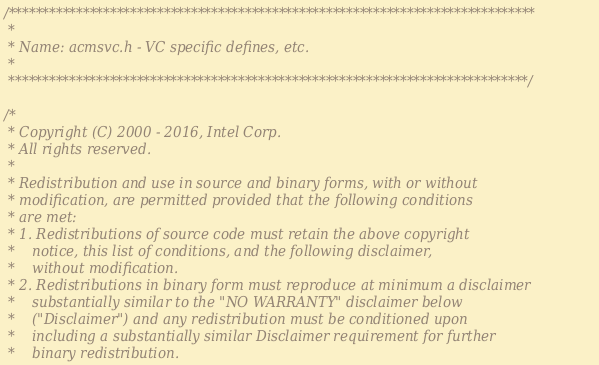<code> <loc_0><loc_0><loc_500><loc_500><_C_>/******************************************************************************
 *
 * Name: acmsvc.h - VC specific defines, etc.
 *
 *****************************************************************************/

/*
 * Copyright (C) 2000 - 2016, Intel Corp.
 * All rights reserved.
 *
 * Redistribution and use in source and binary forms, with or without
 * modification, are permitted provided that the following conditions
 * are met:
 * 1. Redistributions of source code must retain the above copyright
 *    notice, this list of conditions, and the following disclaimer,
 *    without modification.
 * 2. Redistributions in binary form must reproduce at minimum a disclaimer
 *    substantially similar to the "NO WARRANTY" disclaimer below
 *    ("Disclaimer") and any redistribution must be conditioned upon
 *    including a substantially similar Disclaimer requirement for further
 *    binary redistribution.</code> 